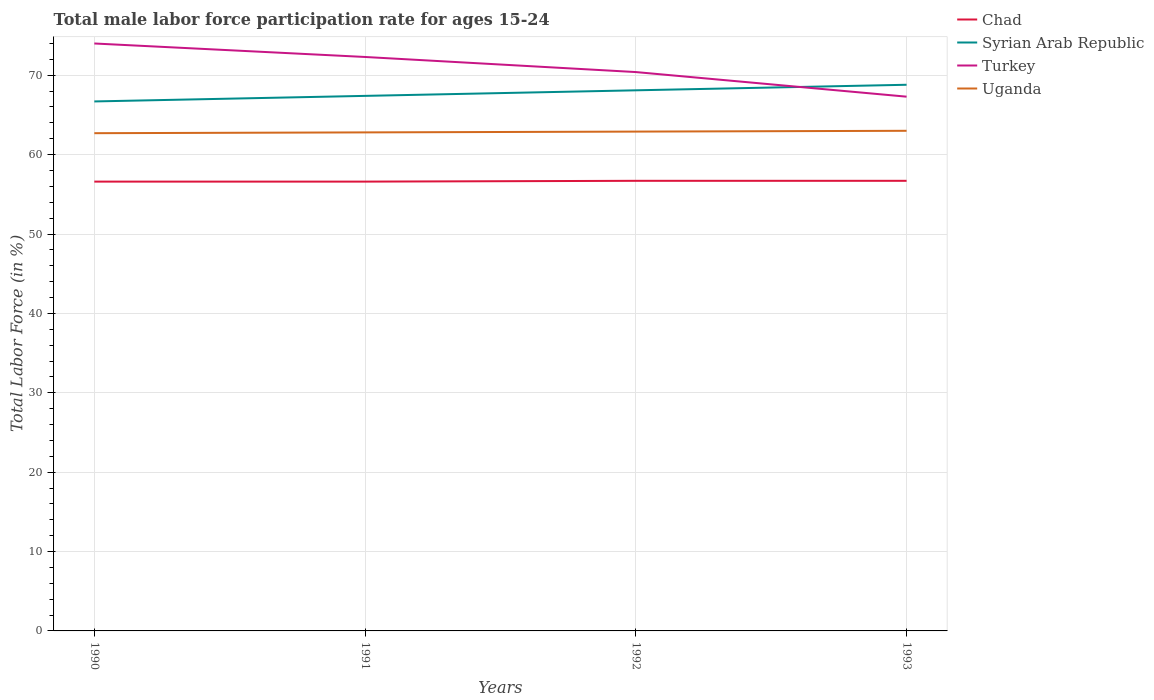How many different coloured lines are there?
Keep it short and to the point. 4. Across all years, what is the maximum male labor force participation rate in Chad?
Offer a terse response. 56.6. In which year was the male labor force participation rate in Turkey maximum?
Your answer should be very brief. 1993. What is the total male labor force participation rate in Uganda in the graph?
Your response must be concise. -0.2. What is the difference between the highest and the second highest male labor force participation rate in Uganda?
Your answer should be very brief. 0.3. Is the male labor force participation rate in Syrian Arab Republic strictly greater than the male labor force participation rate in Uganda over the years?
Provide a succinct answer. No. How many lines are there?
Your answer should be very brief. 4. How many years are there in the graph?
Give a very brief answer. 4. Are the values on the major ticks of Y-axis written in scientific E-notation?
Offer a very short reply. No. Where does the legend appear in the graph?
Your answer should be very brief. Top right. How many legend labels are there?
Make the answer very short. 4. What is the title of the graph?
Provide a short and direct response. Total male labor force participation rate for ages 15-24. What is the label or title of the X-axis?
Your answer should be compact. Years. What is the Total Labor Force (in %) in Chad in 1990?
Your answer should be very brief. 56.6. What is the Total Labor Force (in %) in Syrian Arab Republic in 1990?
Your answer should be very brief. 66.7. What is the Total Labor Force (in %) in Uganda in 1990?
Give a very brief answer. 62.7. What is the Total Labor Force (in %) of Chad in 1991?
Keep it short and to the point. 56.6. What is the Total Labor Force (in %) of Syrian Arab Republic in 1991?
Ensure brevity in your answer.  67.4. What is the Total Labor Force (in %) of Turkey in 1991?
Your response must be concise. 72.3. What is the Total Labor Force (in %) in Uganda in 1991?
Provide a short and direct response. 62.8. What is the Total Labor Force (in %) in Chad in 1992?
Provide a succinct answer. 56.7. What is the Total Labor Force (in %) in Syrian Arab Republic in 1992?
Your response must be concise. 68.1. What is the Total Labor Force (in %) of Turkey in 1992?
Your answer should be very brief. 70.4. What is the Total Labor Force (in %) of Uganda in 1992?
Your response must be concise. 62.9. What is the Total Labor Force (in %) of Chad in 1993?
Your answer should be very brief. 56.7. What is the Total Labor Force (in %) in Syrian Arab Republic in 1993?
Provide a short and direct response. 68.8. What is the Total Labor Force (in %) in Turkey in 1993?
Offer a very short reply. 67.3. Across all years, what is the maximum Total Labor Force (in %) of Chad?
Provide a short and direct response. 56.7. Across all years, what is the maximum Total Labor Force (in %) in Syrian Arab Republic?
Keep it short and to the point. 68.8. Across all years, what is the minimum Total Labor Force (in %) of Chad?
Your answer should be very brief. 56.6. Across all years, what is the minimum Total Labor Force (in %) in Syrian Arab Republic?
Your answer should be very brief. 66.7. Across all years, what is the minimum Total Labor Force (in %) in Turkey?
Provide a succinct answer. 67.3. Across all years, what is the minimum Total Labor Force (in %) in Uganda?
Make the answer very short. 62.7. What is the total Total Labor Force (in %) of Chad in the graph?
Offer a terse response. 226.6. What is the total Total Labor Force (in %) of Syrian Arab Republic in the graph?
Your answer should be very brief. 271. What is the total Total Labor Force (in %) of Turkey in the graph?
Give a very brief answer. 284. What is the total Total Labor Force (in %) in Uganda in the graph?
Your answer should be very brief. 251.4. What is the difference between the Total Labor Force (in %) of Turkey in 1990 and that in 1991?
Provide a succinct answer. 1.7. What is the difference between the Total Labor Force (in %) in Chad in 1990 and that in 1992?
Give a very brief answer. -0.1. What is the difference between the Total Labor Force (in %) of Chad in 1991 and that in 1992?
Ensure brevity in your answer.  -0.1. What is the difference between the Total Labor Force (in %) of Chad in 1991 and that in 1993?
Give a very brief answer. -0.1. What is the difference between the Total Labor Force (in %) in Syrian Arab Republic in 1991 and that in 1993?
Your answer should be very brief. -1.4. What is the difference between the Total Labor Force (in %) of Uganda in 1991 and that in 1993?
Provide a succinct answer. -0.2. What is the difference between the Total Labor Force (in %) of Chad in 1992 and that in 1993?
Your answer should be very brief. 0. What is the difference between the Total Labor Force (in %) in Turkey in 1992 and that in 1993?
Your answer should be very brief. 3.1. What is the difference between the Total Labor Force (in %) of Chad in 1990 and the Total Labor Force (in %) of Syrian Arab Republic in 1991?
Give a very brief answer. -10.8. What is the difference between the Total Labor Force (in %) of Chad in 1990 and the Total Labor Force (in %) of Turkey in 1991?
Provide a short and direct response. -15.7. What is the difference between the Total Labor Force (in %) of Chad in 1990 and the Total Labor Force (in %) of Uganda in 1991?
Make the answer very short. -6.2. What is the difference between the Total Labor Force (in %) of Syrian Arab Republic in 1990 and the Total Labor Force (in %) of Turkey in 1991?
Give a very brief answer. -5.6. What is the difference between the Total Labor Force (in %) of Syrian Arab Republic in 1990 and the Total Labor Force (in %) of Uganda in 1991?
Keep it short and to the point. 3.9. What is the difference between the Total Labor Force (in %) in Turkey in 1990 and the Total Labor Force (in %) in Uganda in 1991?
Keep it short and to the point. 11.2. What is the difference between the Total Labor Force (in %) of Chad in 1990 and the Total Labor Force (in %) of Turkey in 1992?
Make the answer very short. -13.8. What is the difference between the Total Labor Force (in %) of Chad in 1990 and the Total Labor Force (in %) of Uganda in 1992?
Your response must be concise. -6.3. What is the difference between the Total Labor Force (in %) in Chad in 1990 and the Total Labor Force (in %) in Turkey in 1993?
Your response must be concise. -10.7. What is the difference between the Total Labor Force (in %) of Syrian Arab Republic in 1990 and the Total Labor Force (in %) of Turkey in 1993?
Give a very brief answer. -0.6. What is the difference between the Total Labor Force (in %) in Syrian Arab Republic in 1990 and the Total Labor Force (in %) in Uganda in 1993?
Provide a succinct answer. 3.7. What is the difference between the Total Labor Force (in %) of Turkey in 1990 and the Total Labor Force (in %) of Uganda in 1993?
Your response must be concise. 11. What is the difference between the Total Labor Force (in %) in Chad in 1991 and the Total Labor Force (in %) in Syrian Arab Republic in 1992?
Keep it short and to the point. -11.5. What is the difference between the Total Labor Force (in %) in Chad in 1991 and the Total Labor Force (in %) in Turkey in 1992?
Ensure brevity in your answer.  -13.8. What is the difference between the Total Labor Force (in %) of Turkey in 1991 and the Total Labor Force (in %) of Uganda in 1992?
Offer a terse response. 9.4. What is the difference between the Total Labor Force (in %) of Chad in 1991 and the Total Labor Force (in %) of Turkey in 1993?
Give a very brief answer. -10.7. What is the difference between the Total Labor Force (in %) in Chad in 1991 and the Total Labor Force (in %) in Uganda in 1993?
Ensure brevity in your answer.  -6.4. What is the difference between the Total Labor Force (in %) of Turkey in 1991 and the Total Labor Force (in %) of Uganda in 1993?
Ensure brevity in your answer.  9.3. What is the difference between the Total Labor Force (in %) in Chad in 1992 and the Total Labor Force (in %) in Turkey in 1993?
Offer a very short reply. -10.6. What is the difference between the Total Labor Force (in %) in Chad in 1992 and the Total Labor Force (in %) in Uganda in 1993?
Your response must be concise. -6.3. What is the difference between the Total Labor Force (in %) of Syrian Arab Republic in 1992 and the Total Labor Force (in %) of Turkey in 1993?
Your answer should be very brief. 0.8. What is the difference between the Total Labor Force (in %) in Syrian Arab Republic in 1992 and the Total Labor Force (in %) in Uganda in 1993?
Your answer should be very brief. 5.1. What is the difference between the Total Labor Force (in %) of Turkey in 1992 and the Total Labor Force (in %) of Uganda in 1993?
Offer a terse response. 7.4. What is the average Total Labor Force (in %) in Chad per year?
Make the answer very short. 56.65. What is the average Total Labor Force (in %) in Syrian Arab Republic per year?
Make the answer very short. 67.75. What is the average Total Labor Force (in %) in Turkey per year?
Provide a succinct answer. 71. What is the average Total Labor Force (in %) of Uganda per year?
Keep it short and to the point. 62.85. In the year 1990, what is the difference between the Total Labor Force (in %) in Chad and Total Labor Force (in %) in Turkey?
Your answer should be compact. -17.4. In the year 1990, what is the difference between the Total Labor Force (in %) of Syrian Arab Republic and Total Labor Force (in %) of Uganda?
Make the answer very short. 4. In the year 1991, what is the difference between the Total Labor Force (in %) of Chad and Total Labor Force (in %) of Syrian Arab Republic?
Provide a short and direct response. -10.8. In the year 1991, what is the difference between the Total Labor Force (in %) in Chad and Total Labor Force (in %) in Turkey?
Keep it short and to the point. -15.7. In the year 1991, what is the difference between the Total Labor Force (in %) in Syrian Arab Republic and Total Labor Force (in %) in Uganda?
Make the answer very short. 4.6. In the year 1992, what is the difference between the Total Labor Force (in %) of Chad and Total Labor Force (in %) of Syrian Arab Republic?
Offer a terse response. -11.4. In the year 1992, what is the difference between the Total Labor Force (in %) in Chad and Total Labor Force (in %) in Turkey?
Provide a short and direct response. -13.7. In the year 1992, what is the difference between the Total Labor Force (in %) in Chad and Total Labor Force (in %) in Uganda?
Your answer should be very brief. -6.2. In the year 1992, what is the difference between the Total Labor Force (in %) in Syrian Arab Republic and Total Labor Force (in %) in Uganda?
Offer a very short reply. 5.2. In the year 1992, what is the difference between the Total Labor Force (in %) of Turkey and Total Labor Force (in %) of Uganda?
Provide a succinct answer. 7.5. In the year 1993, what is the difference between the Total Labor Force (in %) in Syrian Arab Republic and Total Labor Force (in %) in Turkey?
Make the answer very short. 1.5. In the year 1993, what is the difference between the Total Labor Force (in %) in Syrian Arab Republic and Total Labor Force (in %) in Uganda?
Ensure brevity in your answer.  5.8. What is the ratio of the Total Labor Force (in %) of Syrian Arab Republic in 1990 to that in 1991?
Your response must be concise. 0.99. What is the ratio of the Total Labor Force (in %) of Turkey in 1990 to that in 1991?
Offer a terse response. 1.02. What is the ratio of the Total Labor Force (in %) of Syrian Arab Republic in 1990 to that in 1992?
Provide a short and direct response. 0.98. What is the ratio of the Total Labor Force (in %) in Turkey in 1990 to that in 1992?
Provide a short and direct response. 1.05. What is the ratio of the Total Labor Force (in %) in Chad in 1990 to that in 1993?
Make the answer very short. 1. What is the ratio of the Total Labor Force (in %) in Syrian Arab Republic in 1990 to that in 1993?
Provide a short and direct response. 0.97. What is the ratio of the Total Labor Force (in %) of Turkey in 1990 to that in 1993?
Give a very brief answer. 1.1. What is the ratio of the Total Labor Force (in %) of Uganda in 1991 to that in 1992?
Your answer should be compact. 1. What is the ratio of the Total Labor Force (in %) of Syrian Arab Republic in 1991 to that in 1993?
Offer a terse response. 0.98. What is the ratio of the Total Labor Force (in %) in Turkey in 1991 to that in 1993?
Provide a short and direct response. 1.07. What is the ratio of the Total Labor Force (in %) in Turkey in 1992 to that in 1993?
Offer a terse response. 1.05. What is the ratio of the Total Labor Force (in %) in Uganda in 1992 to that in 1993?
Provide a short and direct response. 1. What is the difference between the highest and the second highest Total Labor Force (in %) of Syrian Arab Republic?
Offer a terse response. 0.7. What is the difference between the highest and the second highest Total Labor Force (in %) in Uganda?
Your answer should be compact. 0.1. What is the difference between the highest and the lowest Total Labor Force (in %) of Syrian Arab Republic?
Ensure brevity in your answer.  2.1. What is the difference between the highest and the lowest Total Labor Force (in %) of Turkey?
Offer a terse response. 6.7. 